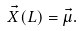Convert formula to latex. <formula><loc_0><loc_0><loc_500><loc_500>\vec { X } ( L ) = \vec { \mu } .</formula> 